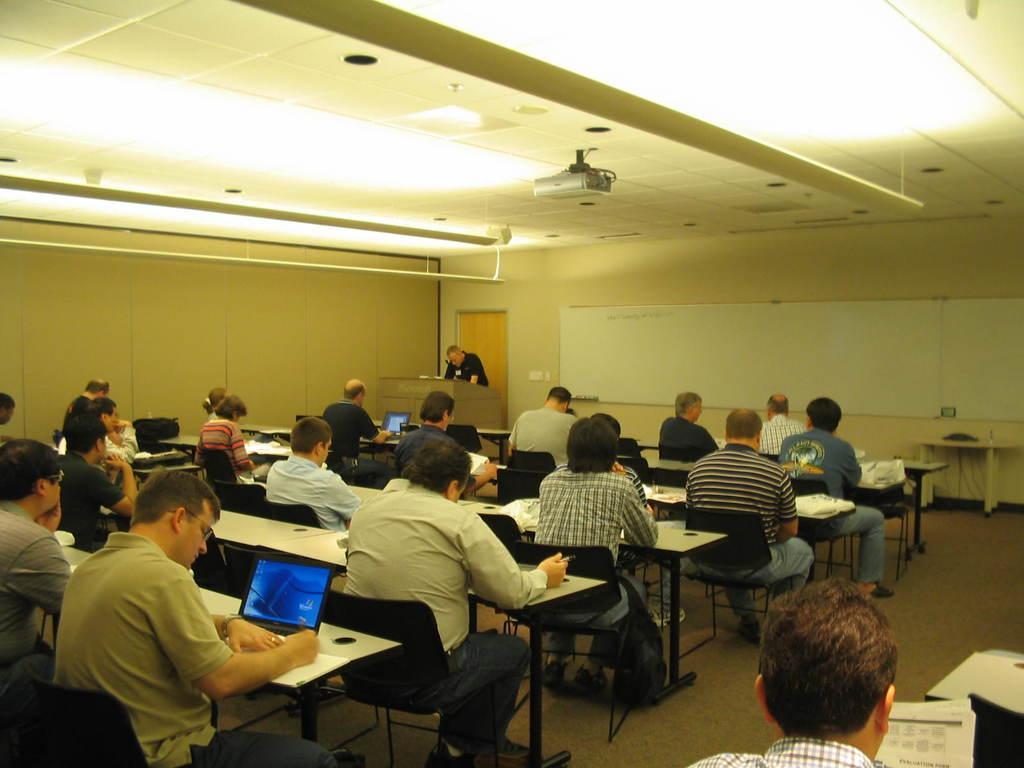In one or two sentences, can you explain what this image depicts? This is a ceiling with lights and projector. Here we can see a white board. We can see one man standing in front of a podium. We can see all the persons sitting on chairs in front of a table and on the table we can see laptops, papers. This is a floor. 